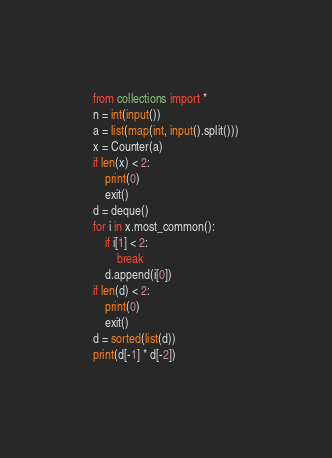<code> <loc_0><loc_0><loc_500><loc_500><_Python_>from collections import *
n = int(input())
a = list(map(int, input().split()))
x = Counter(a)
if len(x) < 2:
    print(0)
    exit()
d = deque()
for i in x.most_common():
    if i[1] < 2:
        break
    d.append(i[0])
if len(d) < 2:
    print(0)
    exit()
d = sorted(list(d))
print(d[-1] * d[-2])
</code> 